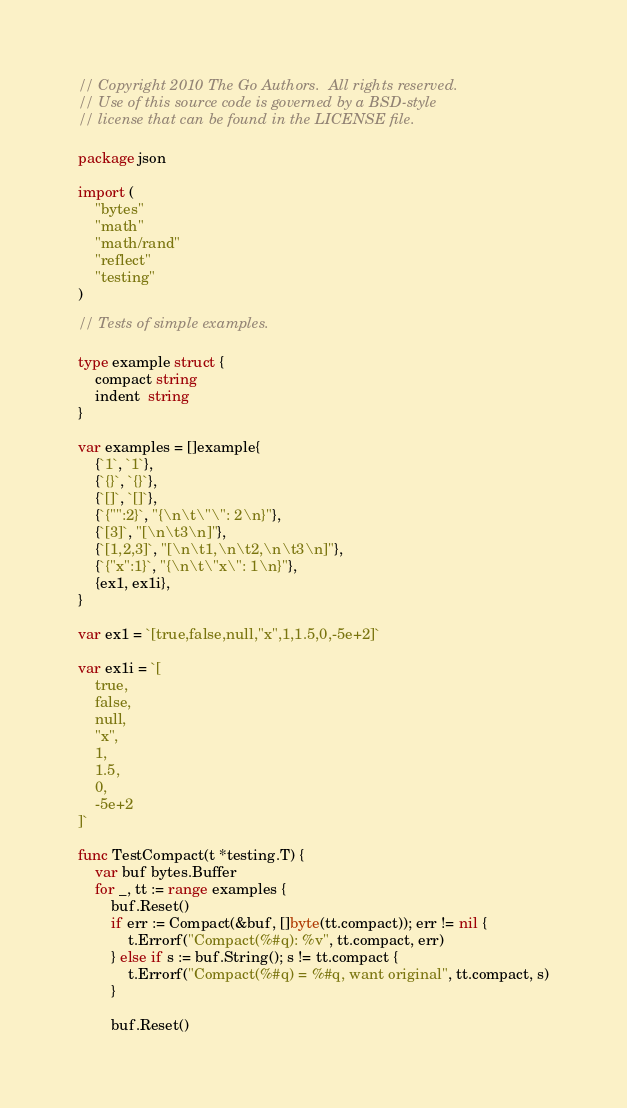Convert code to text. <code><loc_0><loc_0><loc_500><loc_500><_Go_>// Copyright 2010 The Go Authors.  All rights reserved.
// Use of this source code is governed by a BSD-style
// license that can be found in the LICENSE file.

package json

import (
	"bytes"
	"math"
	"math/rand"
	"reflect"
	"testing"
)

// Tests of simple examples.

type example struct {
	compact string
	indent  string
}

var examples = []example{
	{`1`, `1`},
	{`{}`, `{}`},
	{`[]`, `[]`},
	{`{"":2}`, "{\n\t\"\": 2\n}"},
	{`[3]`, "[\n\t3\n]"},
	{`[1,2,3]`, "[\n\t1,\n\t2,\n\t3\n]"},
	{`{"x":1}`, "{\n\t\"x\": 1\n}"},
	{ex1, ex1i},
}

var ex1 = `[true,false,null,"x",1,1.5,0,-5e+2]`

var ex1i = `[
	true,
	false,
	null,
	"x",
	1,
	1.5,
	0,
	-5e+2
]`

func TestCompact(t *testing.T) {
	var buf bytes.Buffer
	for _, tt := range examples {
		buf.Reset()
		if err := Compact(&buf, []byte(tt.compact)); err != nil {
			t.Errorf("Compact(%#q): %v", tt.compact, err)
		} else if s := buf.String(); s != tt.compact {
			t.Errorf("Compact(%#q) = %#q, want original", tt.compact, s)
		}

		buf.Reset()</code> 